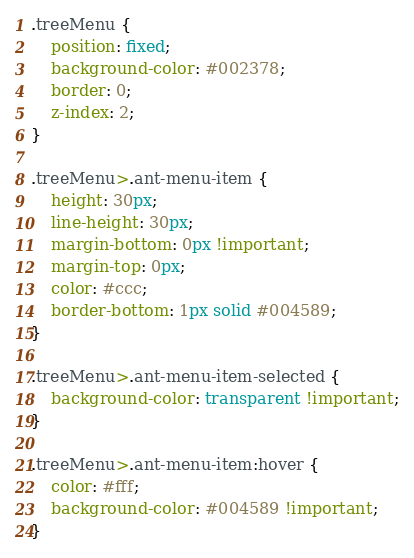<code> <loc_0><loc_0><loc_500><loc_500><_CSS_>.treeMenu {
    position: fixed;
    background-color: #002378;
    border: 0;
    z-index: 2;
}

.treeMenu>.ant-menu-item {
    height: 30px;
    line-height: 30px;
    margin-bottom: 0px !important;
    margin-top: 0px;
    color: #ccc;
    border-bottom: 1px solid #004589;
}

.treeMenu>.ant-menu-item-selected {
    background-color: transparent !important;
}

.treeMenu>.ant-menu-item:hover {
    color: #fff;
    background-color: #004589 !important;
}</code> 